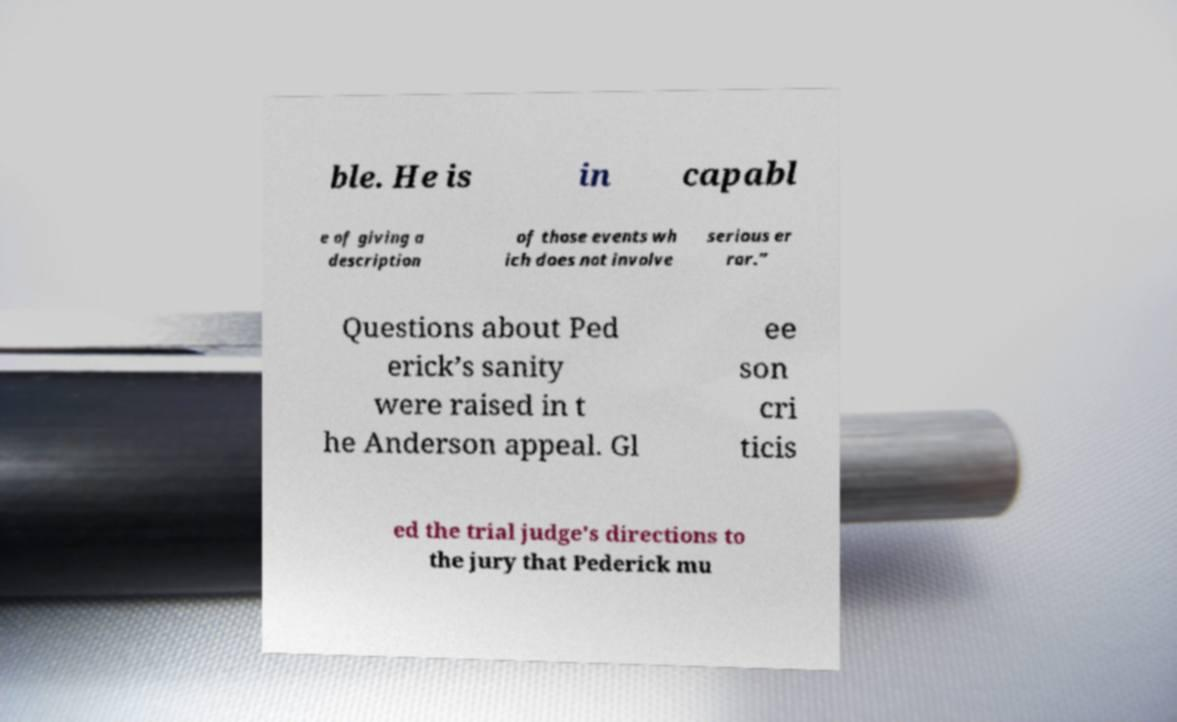Please identify and transcribe the text found in this image. ble. He is in capabl e of giving a description of those events wh ich does not involve serious er ror.” Questions about Ped erick’s sanity were raised in t he Anderson appeal. Gl ee son cri ticis ed the trial judge's directions to the jury that Pederick mu 